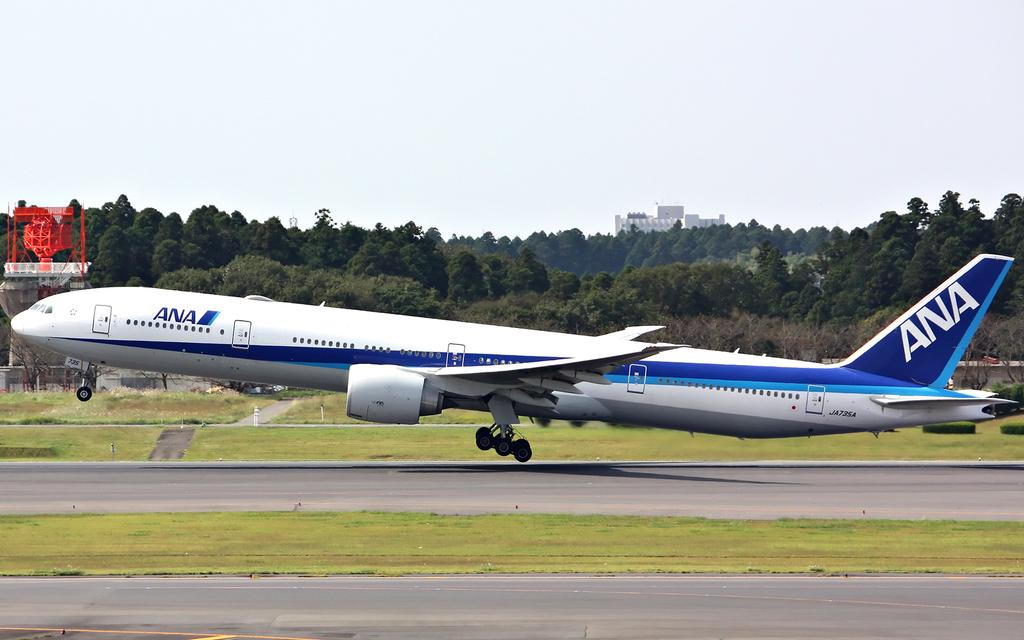<image>
Relay a brief, clear account of the picture shown. an ANA airplane is taking off from a runway somewhere 